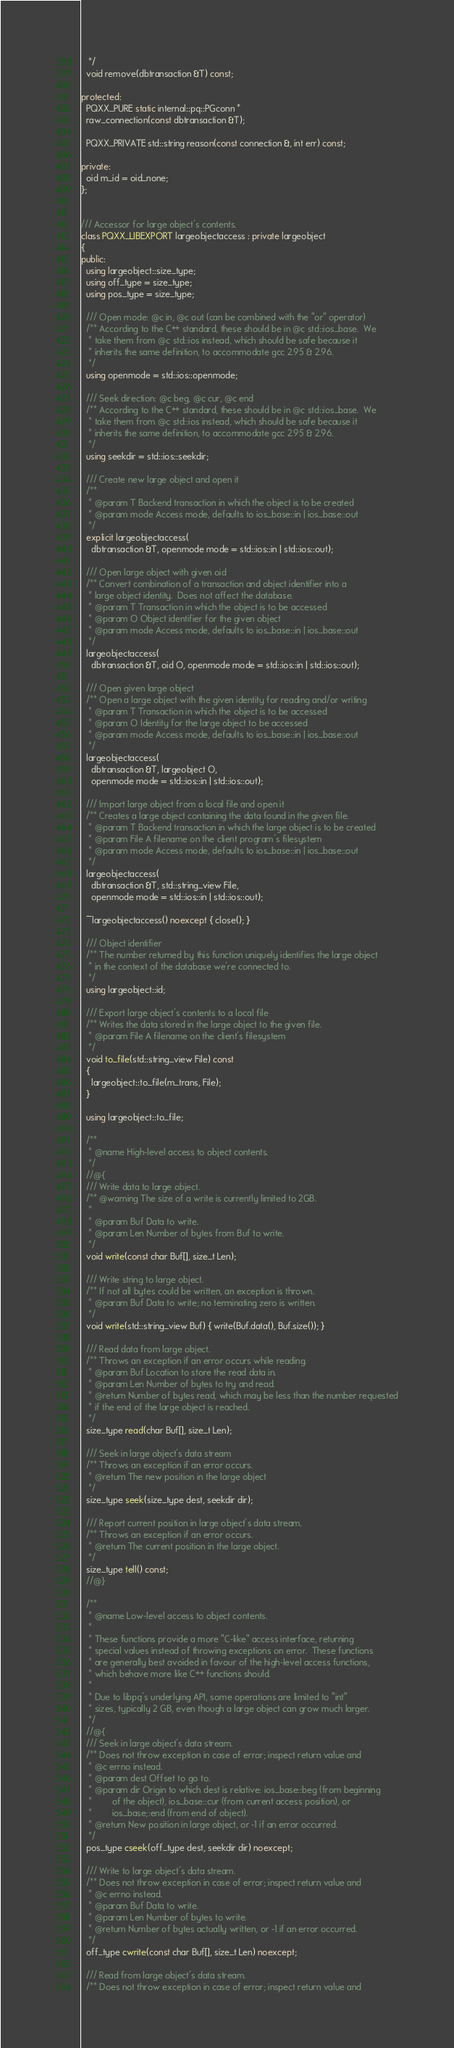Convert code to text. <code><loc_0><loc_0><loc_500><loc_500><_C++_>   */
  void remove(dbtransaction &T) const;

protected:
  PQXX_PURE static internal::pq::PGconn *
  raw_connection(const dbtransaction &T);

  PQXX_PRIVATE std::string reason(const connection &, int err) const;

private:
  oid m_id = oid_none;
};


/// Accessor for large object's contents.
class PQXX_LIBEXPORT largeobjectaccess : private largeobject
{
public:
  using largeobject::size_type;
  using off_type = size_type;
  using pos_type = size_type;

  /// Open mode: @c in, @c out (can be combined with the "or" operator)
  /** According to the C++ standard, these should be in @c std::ios_base.  We
   * take them from @c std::ios instead, which should be safe because it
   * inherits the same definition, to accommodate gcc 2.95 & 2.96.
   */
  using openmode = std::ios::openmode;

  /// Seek direction: @c beg, @c cur, @c end
  /** According to the C++ standard, these should be in @c std::ios_base.  We
   * take them from @c std::ios instead, which should be safe because it
   * inherits the same definition, to accommodate gcc 2.95 & 2.96.
   */
  using seekdir = std::ios::seekdir;

  /// Create new large object and open it
  /**
   * @param T Backend transaction in which the object is to be created
   * @param mode Access mode, defaults to ios_base::in | ios_base::out
   */
  explicit largeobjectaccess(
    dbtransaction &T, openmode mode = std::ios::in | std::ios::out);

  /// Open large object with given oid
  /** Convert combination of a transaction and object identifier into a
   * large object identity.  Does not affect the database.
   * @param T Transaction in which the object is to be accessed
   * @param O Object identifier for the given object
   * @param mode Access mode, defaults to ios_base::in | ios_base::out
   */
  largeobjectaccess(
    dbtransaction &T, oid O, openmode mode = std::ios::in | std::ios::out);

  /// Open given large object
  /** Open a large object with the given identity for reading and/or writing
   * @param T Transaction in which the object is to be accessed
   * @param O Identity for the large object to be accessed
   * @param mode Access mode, defaults to ios_base::in | ios_base::out
   */
  largeobjectaccess(
    dbtransaction &T, largeobject O,
    openmode mode = std::ios::in | std::ios::out);

  /// Import large object from a local file and open it
  /** Creates a large object containing the data found in the given file.
   * @param T Backend transaction in which the large object is to be created
   * @param File A filename on the client program's filesystem
   * @param mode Access mode, defaults to ios_base::in | ios_base::out
   */
  largeobjectaccess(
    dbtransaction &T, std::string_view File,
    openmode mode = std::ios::in | std::ios::out);

  ~largeobjectaccess() noexcept { close(); }

  /// Object identifier
  /** The number returned by this function uniquely identifies the large object
   * in the context of the database we're connected to.
   */
  using largeobject::id;

  /// Export large object's contents to a local file
  /** Writes the data stored in the large object to the given file.
   * @param File A filename on the client's filesystem
   */
  void to_file(std::string_view File) const
  {
    largeobject::to_file(m_trans, File);
  }

  using largeobject::to_file;

  /**
   * @name High-level access to object contents.
   */
  //@{
  /// Write data to large object.
  /** @warning The size of a write is currently limited to 2GB.
   *
   * @param Buf Data to write.
   * @param Len Number of bytes from Buf to write.
   */
  void write(const char Buf[], size_t Len);

  /// Write string to large object.
  /** If not all bytes could be written, an exception is thrown.
   * @param Buf Data to write; no terminating zero is written.
   */
  void write(std::string_view Buf) { write(Buf.data(), Buf.size()); }

  /// Read data from large object.
  /** Throws an exception if an error occurs while reading.
   * @param Buf Location to store the read data in.
   * @param Len Number of bytes to try and read.
   * @return Number of bytes read, which may be less than the number requested
   * if the end of the large object is reached.
   */
  size_type read(char Buf[], size_t Len);

  /// Seek in large object's data stream
  /** Throws an exception if an error occurs.
   * @return The new position in the large object
   */
  size_type seek(size_type dest, seekdir dir);

  /// Report current position in large object's data stream.
  /** Throws an exception if an error occurs.
   * @return The current position in the large object.
   */
  size_type tell() const;
  //@}

  /**
   * @name Low-level access to object contents.
   *
   * These functions provide a more "C-like" access interface, returning
   * special values instead of throwing exceptions on error.  These functions
   * are generally best avoided in favour of the high-level access functions,
   * which behave more like C++ functions should.
   *
   * Due to libpq's underlying API, some operations are limited to "int"
   * sizes, typically 2 GB, even though a large object can grow much larger.
   */
  //@{
  /// Seek in large object's data stream.
  /** Does not throw exception in case of error; inspect return value and
   * @c errno instead.
   * @param dest Offset to go to.
   * @param dir Origin to which dest is relative: ios_base::beg (from beginning
   *        of the object), ios_base::cur (from current access position), or
   *        ios_base;:end (from end of object).
   * @return New position in large object, or -1 if an error occurred.
   */
  pos_type cseek(off_type dest, seekdir dir) noexcept;

  /// Write to large object's data stream.
  /** Does not throw exception in case of error; inspect return value and
   * @c errno instead.
   * @param Buf Data to write.
   * @param Len Number of bytes to write.
   * @return Number of bytes actually written, or -1 if an error occurred.
   */
  off_type cwrite(const char Buf[], size_t Len) noexcept;

  /// Read from large object's data stream.
  /** Does not throw exception in case of error; inspect return value and</code> 